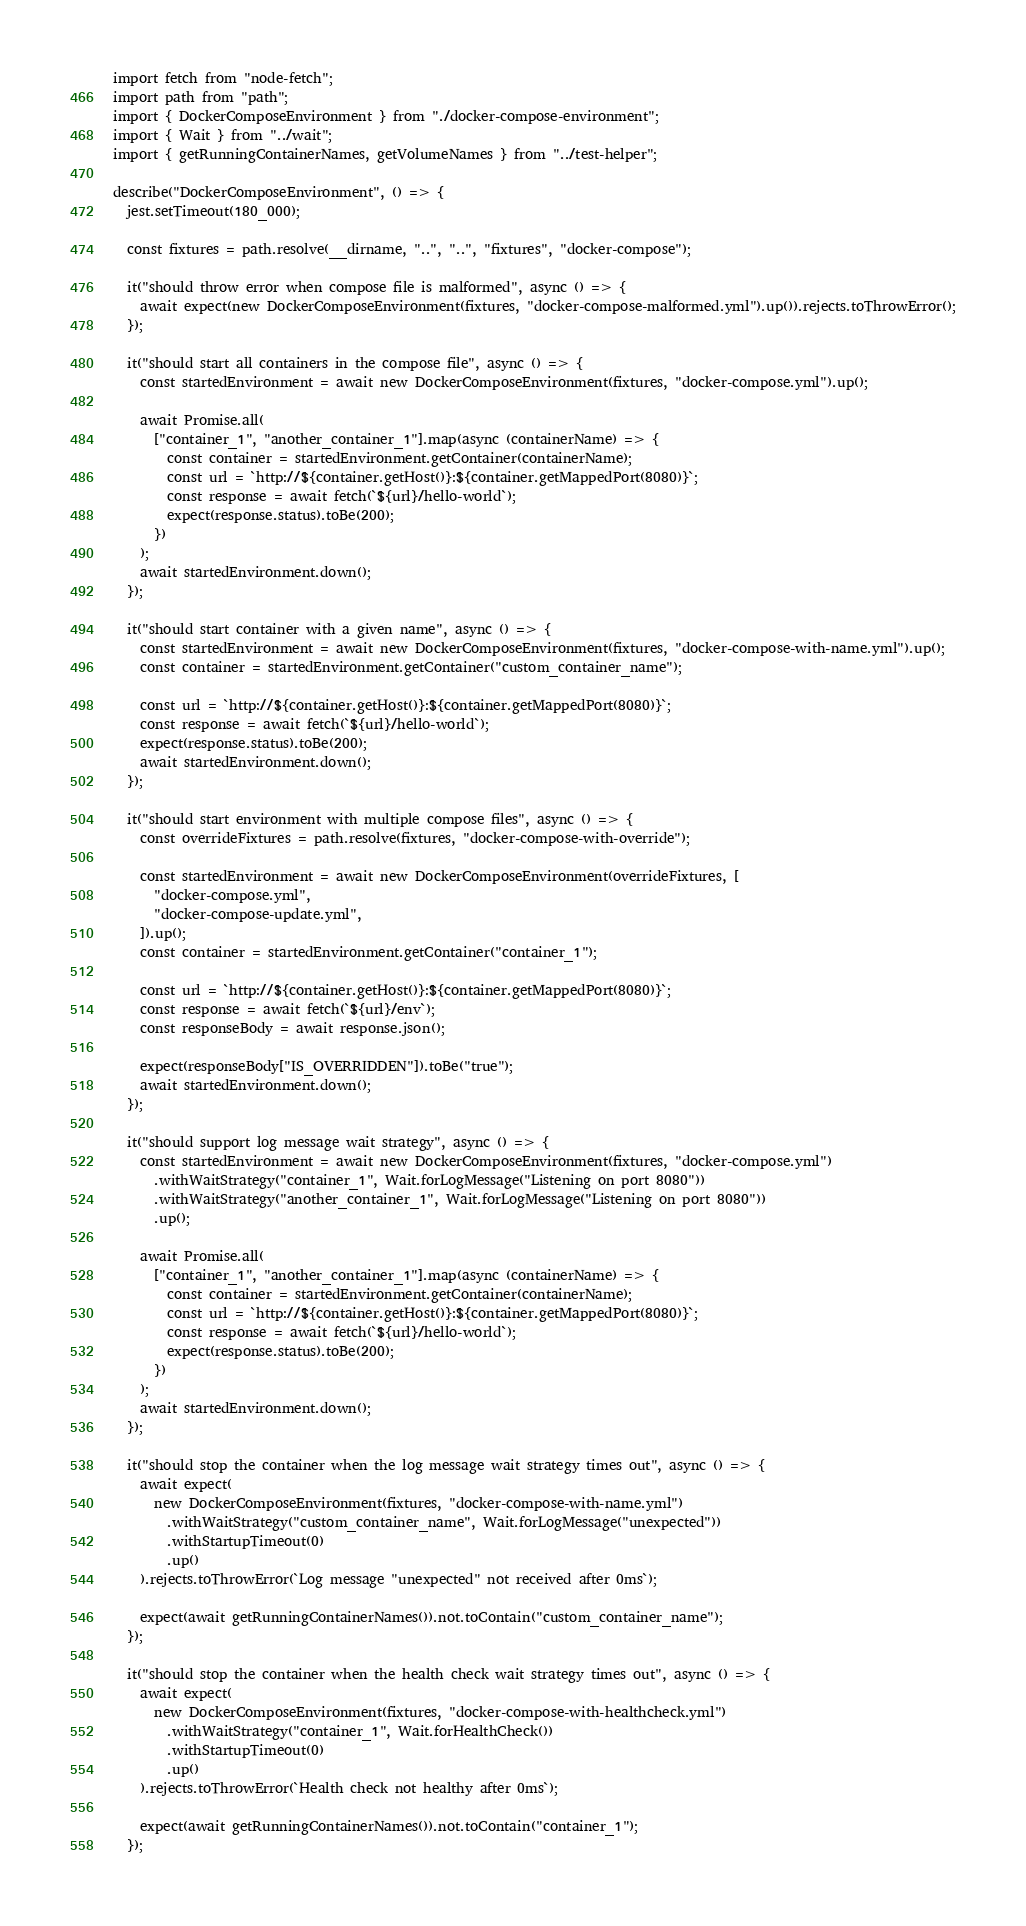Convert code to text. <code><loc_0><loc_0><loc_500><loc_500><_TypeScript_>import fetch from "node-fetch";
import path from "path";
import { DockerComposeEnvironment } from "./docker-compose-environment";
import { Wait } from "../wait";
import { getRunningContainerNames, getVolumeNames } from "../test-helper";

describe("DockerComposeEnvironment", () => {
  jest.setTimeout(180_000);

  const fixtures = path.resolve(__dirname, "..", "..", "fixtures", "docker-compose");

  it("should throw error when compose file is malformed", async () => {
    await expect(new DockerComposeEnvironment(fixtures, "docker-compose-malformed.yml").up()).rejects.toThrowError();
  });

  it("should start all containers in the compose file", async () => {
    const startedEnvironment = await new DockerComposeEnvironment(fixtures, "docker-compose.yml").up();

    await Promise.all(
      ["container_1", "another_container_1"].map(async (containerName) => {
        const container = startedEnvironment.getContainer(containerName);
        const url = `http://${container.getHost()}:${container.getMappedPort(8080)}`;
        const response = await fetch(`${url}/hello-world`);
        expect(response.status).toBe(200);
      })
    );
    await startedEnvironment.down();
  });

  it("should start container with a given name", async () => {
    const startedEnvironment = await new DockerComposeEnvironment(fixtures, "docker-compose-with-name.yml").up();
    const container = startedEnvironment.getContainer("custom_container_name");

    const url = `http://${container.getHost()}:${container.getMappedPort(8080)}`;
    const response = await fetch(`${url}/hello-world`);
    expect(response.status).toBe(200);
    await startedEnvironment.down();
  });

  it("should start environment with multiple compose files", async () => {
    const overrideFixtures = path.resolve(fixtures, "docker-compose-with-override");

    const startedEnvironment = await new DockerComposeEnvironment(overrideFixtures, [
      "docker-compose.yml",
      "docker-compose-update.yml",
    ]).up();
    const container = startedEnvironment.getContainer("container_1");

    const url = `http://${container.getHost()}:${container.getMappedPort(8080)}`;
    const response = await fetch(`${url}/env`);
    const responseBody = await response.json();

    expect(responseBody["IS_OVERRIDDEN"]).toBe("true");
    await startedEnvironment.down();
  });

  it("should support log message wait strategy", async () => {
    const startedEnvironment = await new DockerComposeEnvironment(fixtures, "docker-compose.yml")
      .withWaitStrategy("container_1", Wait.forLogMessage("Listening on port 8080"))
      .withWaitStrategy("another_container_1", Wait.forLogMessage("Listening on port 8080"))
      .up();

    await Promise.all(
      ["container_1", "another_container_1"].map(async (containerName) => {
        const container = startedEnvironment.getContainer(containerName);
        const url = `http://${container.getHost()}:${container.getMappedPort(8080)}`;
        const response = await fetch(`${url}/hello-world`);
        expect(response.status).toBe(200);
      })
    );
    await startedEnvironment.down();
  });

  it("should stop the container when the log message wait strategy times out", async () => {
    await expect(
      new DockerComposeEnvironment(fixtures, "docker-compose-with-name.yml")
        .withWaitStrategy("custom_container_name", Wait.forLogMessage("unexpected"))
        .withStartupTimeout(0)
        .up()
    ).rejects.toThrowError(`Log message "unexpected" not received after 0ms`);

    expect(await getRunningContainerNames()).not.toContain("custom_container_name");
  });

  it("should stop the container when the health check wait strategy times out", async () => {
    await expect(
      new DockerComposeEnvironment(fixtures, "docker-compose-with-healthcheck.yml")
        .withWaitStrategy("container_1", Wait.forHealthCheck())
        .withStartupTimeout(0)
        .up()
    ).rejects.toThrowError(`Health check not healthy after 0ms`);

    expect(await getRunningContainerNames()).not.toContain("container_1");
  });
</code> 